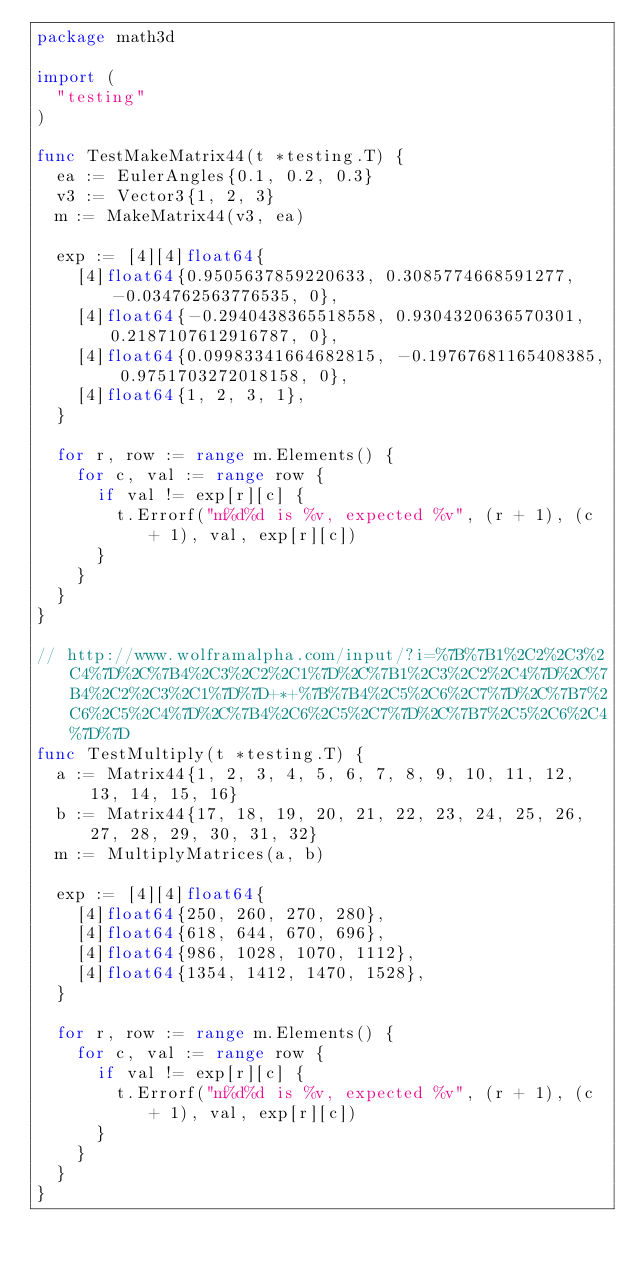<code> <loc_0><loc_0><loc_500><loc_500><_Go_>package math3d

import (
	"testing"
)

func TestMakeMatrix44(t *testing.T) {
	ea := EulerAngles{0.1, 0.2, 0.3}
	v3 := Vector3{1, 2, 3}
	m := MakeMatrix44(v3, ea)

	exp := [4][4]float64{
		[4]float64{0.9505637859220633, 0.3085774668591277, -0.034762563776535, 0},
		[4]float64{-0.2940438365518558, 0.9304320636570301, 0.2187107612916787, 0},
		[4]float64{0.09983341664682815, -0.19767681165408385, 0.9751703272018158, 0},
		[4]float64{1, 2, 3, 1},
	}

	for r, row := range m.Elements() {
		for c, val := range row {
			if val != exp[r][c] {
				t.Errorf("m%d%d is %v, expected %v", (r + 1), (c + 1), val, exp[r][c])
			}
		}
	}
}

// http://www.wolframalpha.com/input/?i=%7B%7B1%2C2%2C3%2C4%7D%2C%7B4%2C3%2C2%2C1%7D%2C%7B1%2C3%2C2%2C4%7D%2C%7B4%2C2%2C3%2C1%7D%7D+*+%7B%7B4%2C5%2C6%2C7%7D%2C%7B7%2C6%2C5%2C4%7D%2C%7B4%2C6%2C5%2C7%7D%2C%7B7%2C5%2C6%2C4%7D%7D
func TestMultiply(t *testing.T) {
	a := Matrix44{1, 2, 3, 4, 5, 6, 7, 8, 9, 10, 11, 12, 13, 14, 15, 16}
	b := Matrix44{17, 18, 19, 20, 21, 22, 23, 24, 25, 26, 27, 28, 29, 30, 31, 32}
	m := MultiplyMatrices(a, b)

	exp := [4][4]float64{
		[4]float64{250, 260, 270, 280},
		[4]float64{618, 644, 670, 696},
		[4]float64{986, 1028, 1070, 1112},
		[4]float64{1354, 1412, 1470, 1528},
	}

	for r, row := range m.Elements() {
		for c, val := range row {
			if val != exp[r][c] {
				t.Errorf("m%d%d is %v, expected %v", (r + 1), (c + 1), val, exp[r][c])
			}
		}
	}
}
</code> 